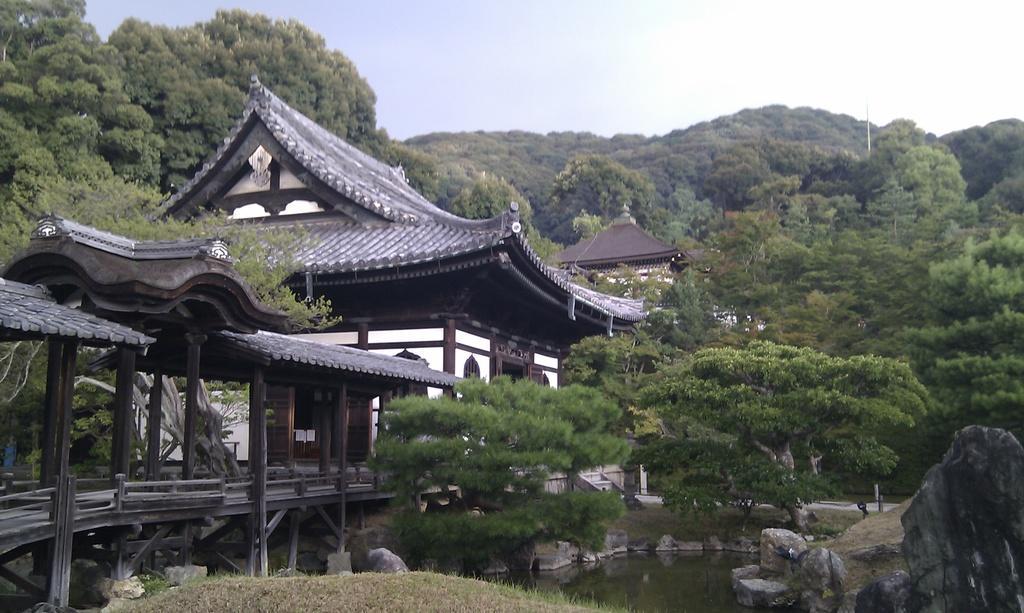How would you summarize this image in a sentence or two? In the center of the image we can see chinese temples. In the background of the image trees are present. At the bottom of the image water and rocks, grass are there. At the top of the image sky is present. 